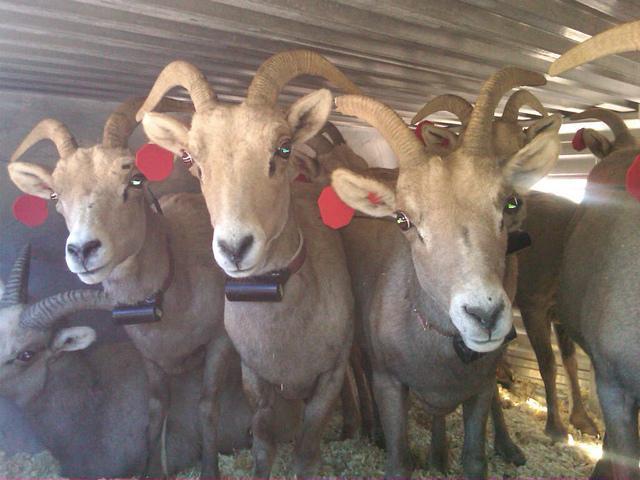How many sheep can be seen?
Give a very brief answer. 5. How many people are in the water?
Give a very brief answer. 0. 